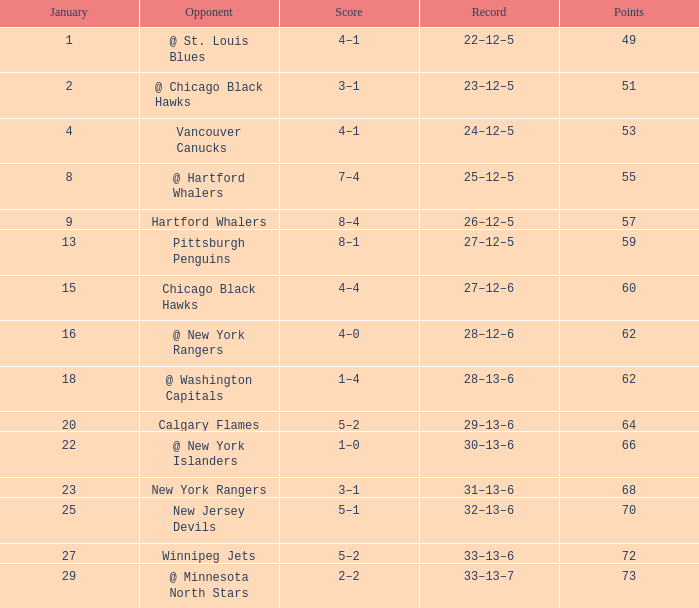Which Points is the lowest one that has a Score of 1–4, and a January smaller than 18? None. 